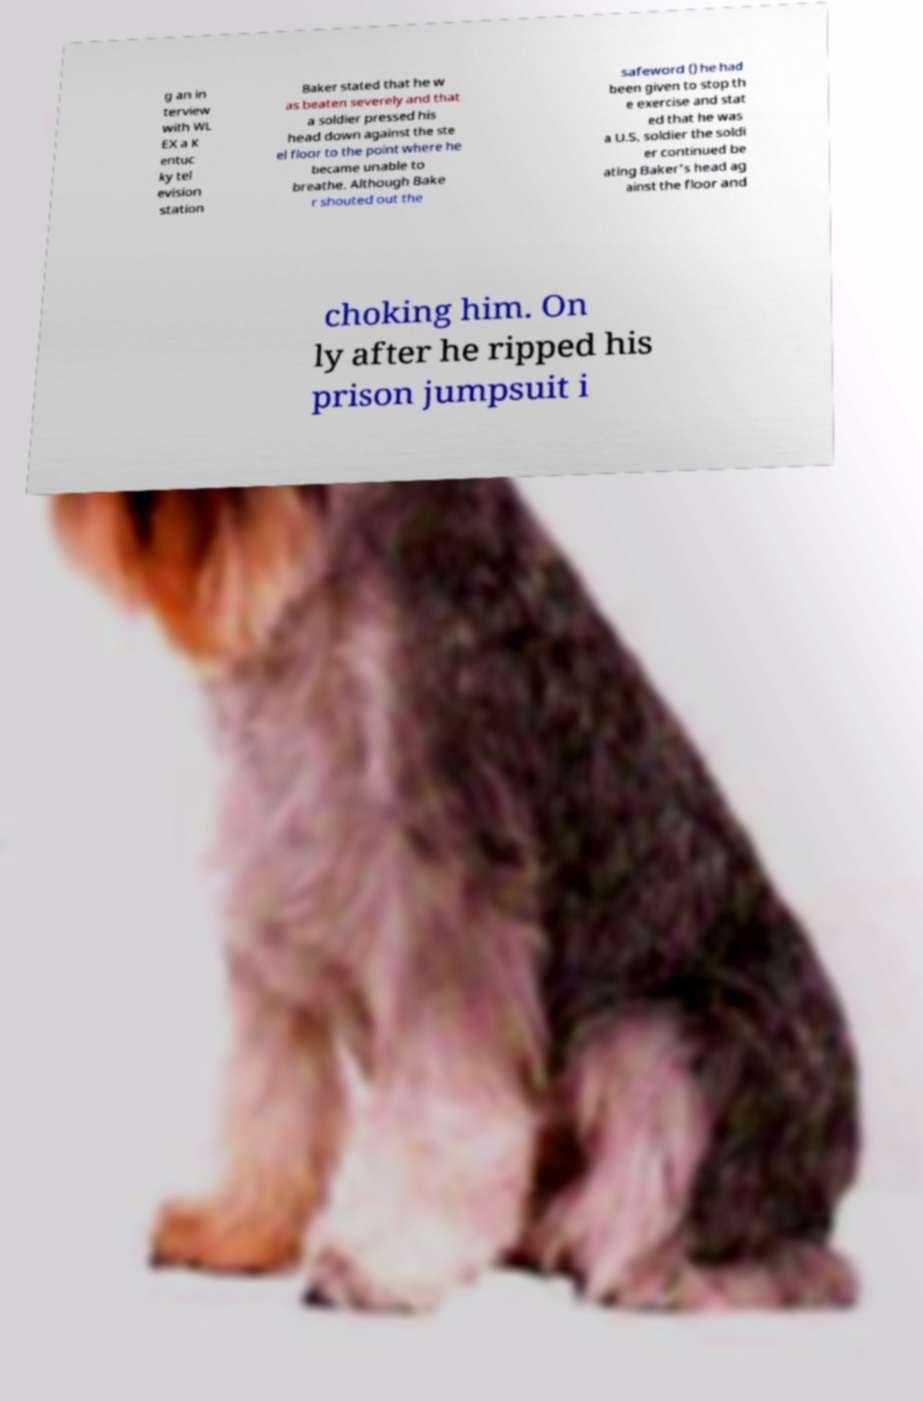Can you read and provide the text displayed in the image?This photo seems to have some interesting text. Can you extract and type it out for me? g an in terview with WL EX a K entuc ky tel evision station Baker stated that he w as beaten severely and that a soldier pressed his head down against the ste el floor to the point where he became unable to breathe. Although Bake r shouted out the safeword () he had been given to stop th e exercise and stat ed that he was a U.S. soldier the soldi er continued be ating Baker's head ag ainst the floor and choking him. On ly after he ripped his prison jumpsuit i 